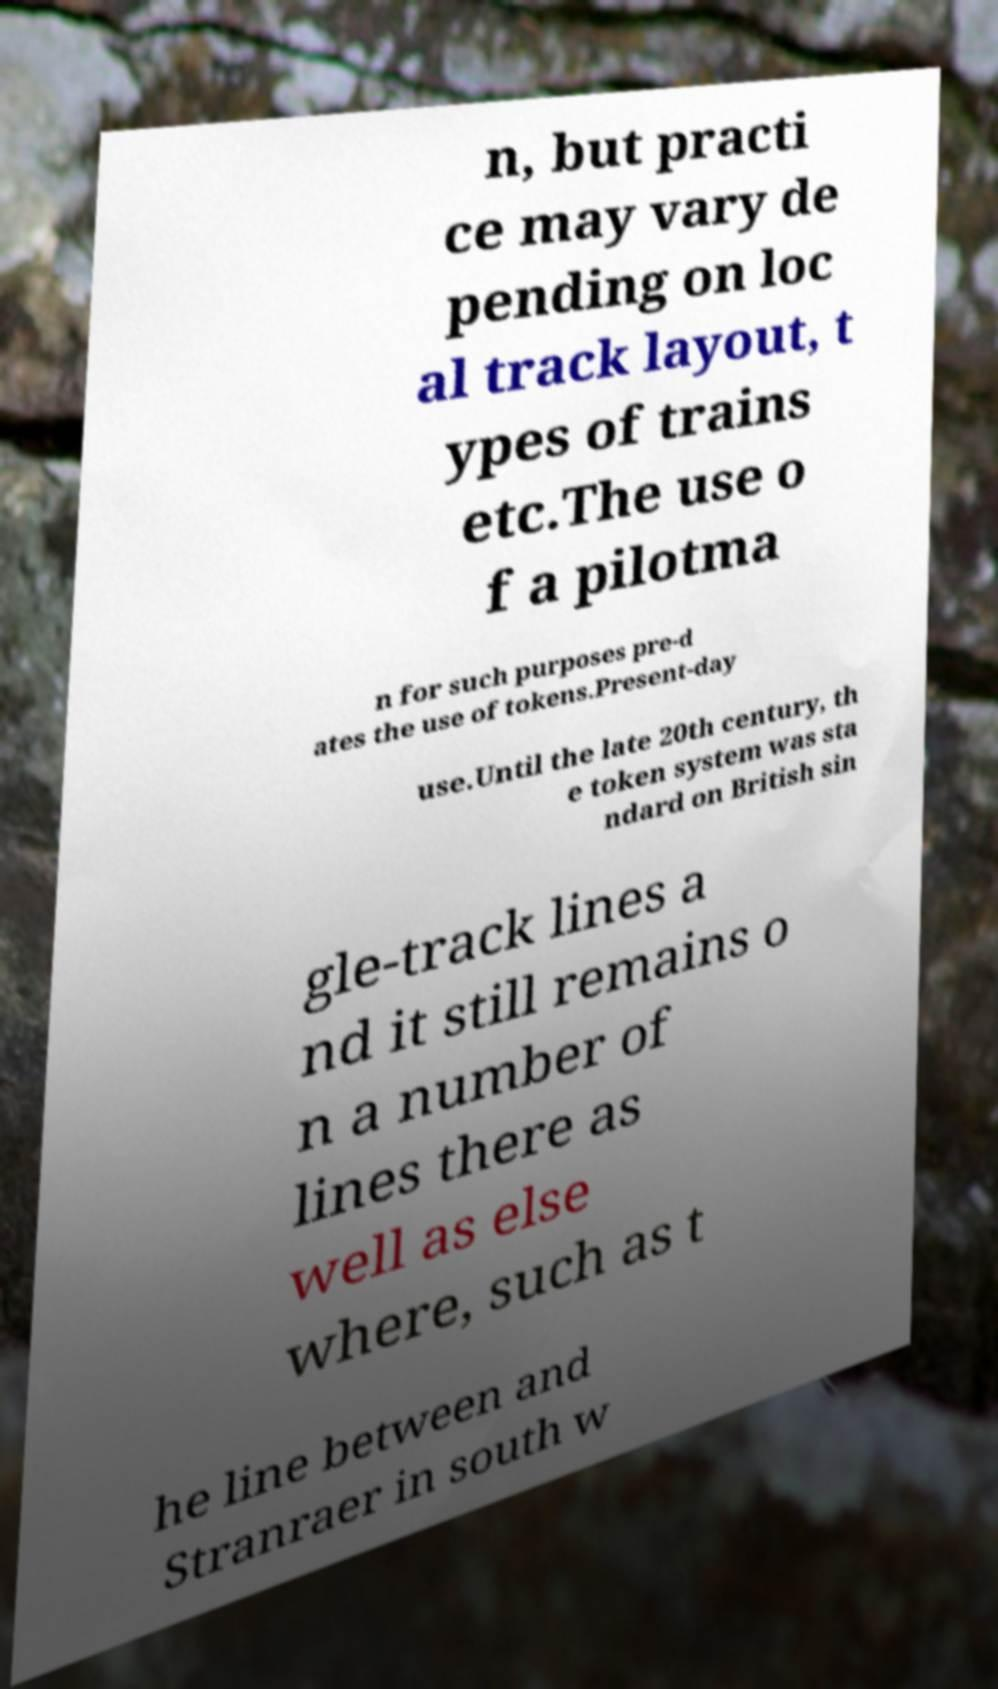What messages or text are displayed in this image? I need them in a readable, typed format. n, but practi ce may vary de pending on loc al track layout, t ypes of trains etc.The use o f a pilotma n for such purposes pre-d ates the use of tokens.Present-day use.Until the late 20th century, th e token system was sta ndard on British sin gle-track lines a nd it still remains o n a number of lines there as well as else where, such as t he line between and Stranraer in south w 